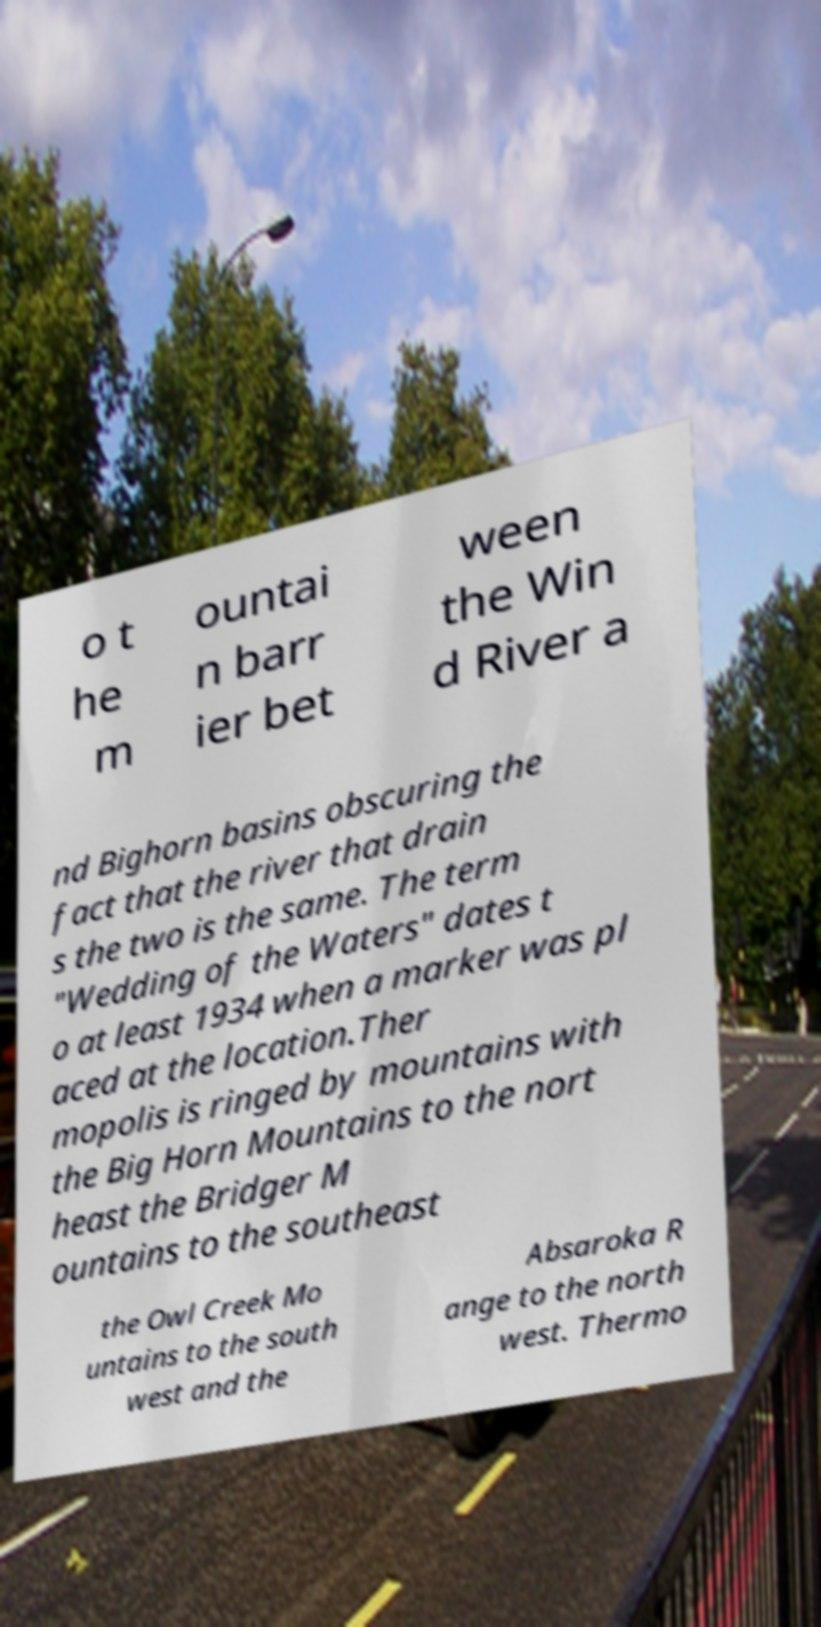Please identify and transcribe the text found in this image. o t he m ountai n barr ier bet ween the Win d River a nd Bighorn basins obscuring the fact that the river that drain s the two is the same. The term "Wedding of the Waters" dates t o at least 1934 when a marker was pl aced at the location.Ther mopolis is ringed by mountains with the Big Horn Mountains to the nort heast the Bridger M ountains to the southeast the Owl Creek Mo untains to the south west and the Absaroka R ange to the north west. Thermo 